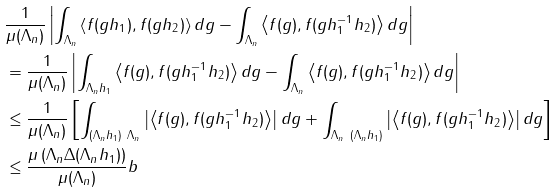<formula> <loc_0><loc_0><loc_500><loc_500>& \frac { 1 } { \mu ( \Lambda _ { n } ) } \left | \int _ { \Lambda _ { n } } \left \langle f ( g h _ { 1 } ) , f ( g h _ { 2 } ) \right \rangle d g - \int _ { \Lambda _ { n } } \left \langle f ( g ) , f ( g h _ { 1 } ^ { - 1 } h _ { 2 } ) \right \rangle d g \right | \\ & = \frac { 1 } { \mu ( \Lambda _ { n } ) } \left | \int _ { \Lambda _ { n } h _ { 1 } } \left \langle f ( g ) , f ( g h _ { 1 } ^ { - 1 } h _ { 2 } ) \right \rangle d g - \int _ { \Lambda _ { n } } \left \langle f ( g ) , f ( g h _ { 1 } ^ { - 1 } h _ { 2 } ) \right \rangle d g \right | \\ & \leq \frac { 1 } { \mu ( \Lambda _ { n } ) } \left [ \int _ { ( \Lambda _ { n } h _ { 1 } ) \ \Lambda _ { n } } \left | \left \langle f ( g ) , f ( g h _ { 1 } ^ { - 1 } h _ { 2 } ) \right \rangle \right | d g + \int _ { \Lambda _ { n } \ ( \Lambda _ { n } h _ { 1 } ) } \left | \left \langle f ( g ) , f ( g h _ { 1 } ^ { - 1 } h _ { 2 } ) \right \rangle \right | d g \right ] \\ & \leq \frac { \mu \left ( \Lambda _ { n } \Delta ( \Lambda _ { n } h _ { 1 } ) \right ) } { \mu ( \Lambda _ { n } ) } b</formula> 